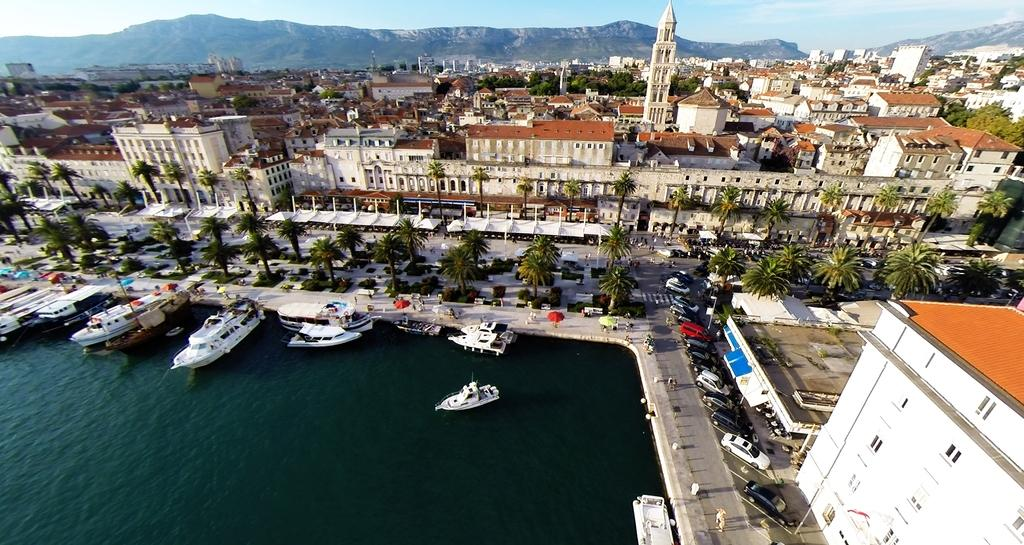What can be seen on the water in the image? There are ships on the water in the image. What can be seen on the road in the image? There are vehicles on the road in the image. What type of vegetation is present in the image? There are trees in the image. What type of structures are visible in the image? There are many buildings in the image. What is visible in the background of the image? There are mountains visible in the background of the image. What type of disgust can be seen on the fan in the image? There is no fan or disgust present in the image. What type of hook is visible on the trees in the image? There is no hook present on the trees in the image. 